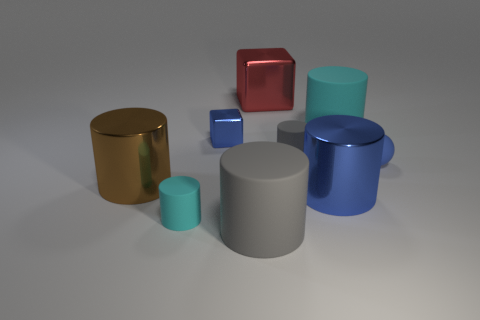There is a gray rubber object that is the same size as the blue sphere; what is its shape?
Provide a short and direct response. Cylinder. Are there any large shiny objects of the same color as the ball?
Provide a succinct answer. Yes. Do the big blue object and the tiny gray rubber object have the same shape?
Offer a terse response. Yes. How many tiny things are either green metal objects or blue cylinders?
Offer a terse response. 0. The big thing that is made of the same material as the big cyan cylinder is what color?
Your response must be concise. Gray. What number of big cubes are made of the same material as the small blue cube?
Your answer should be compact. 1. There is a cyan matte cylinder that is behind the small cyan rubber cylinder; does it have the same size as the cyan matte cylinder left of the big gray matte thing?
Offer a very short reply. No. There is a big cylinder that is behind the gray rubber cylinder right of the large red shiny thing; what is its material?
Provide a short and direct response. Rubber. Are there fewer red blocks that are in front of the large cyan object than large gray rubber cylinders left of the tiny blue rubber object?
Provide a short and direct response. Yes. There is a tiny sphere that is the same color as the small metallic object; what is its material?
Keep it short and to the point. Rubber. 